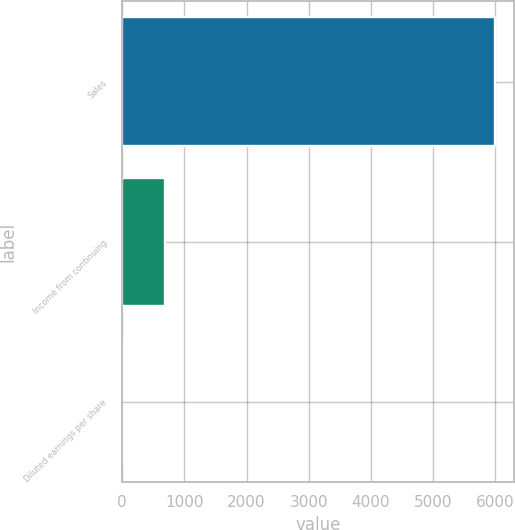Convert chart to OTSL. <chart><loc_0><loc_0><loc_500><loc_500><bar_chart><fcel>Sales<fcel>Income from continuing<fcel>Diluted earnings per share<nl><fcel>6000.4<fcel>697.1<fcel>4.79<nl></chart> 